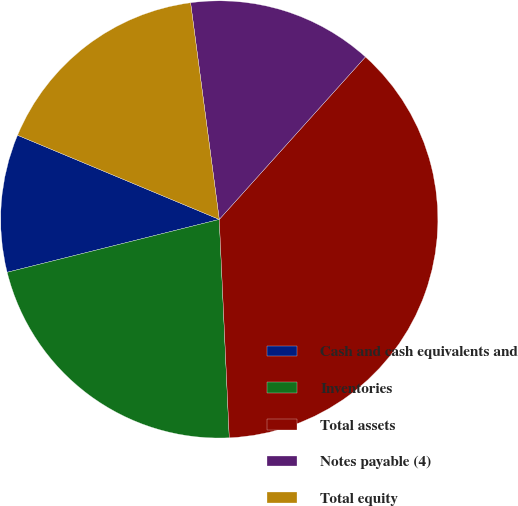<chart> <loc_0><loc_0><loc_500><loc_500><pie_chart><fcel>Cash and cash equivalents and<fcel>Inventories<fcel>Total assets<fcel>Notes payable (4)<fcel>Total equity<nl><fcel>10.18%<fcel>21.84%<fcel>37.61%<fcel>13.75%<fcel>16.61%<nl></chart> 